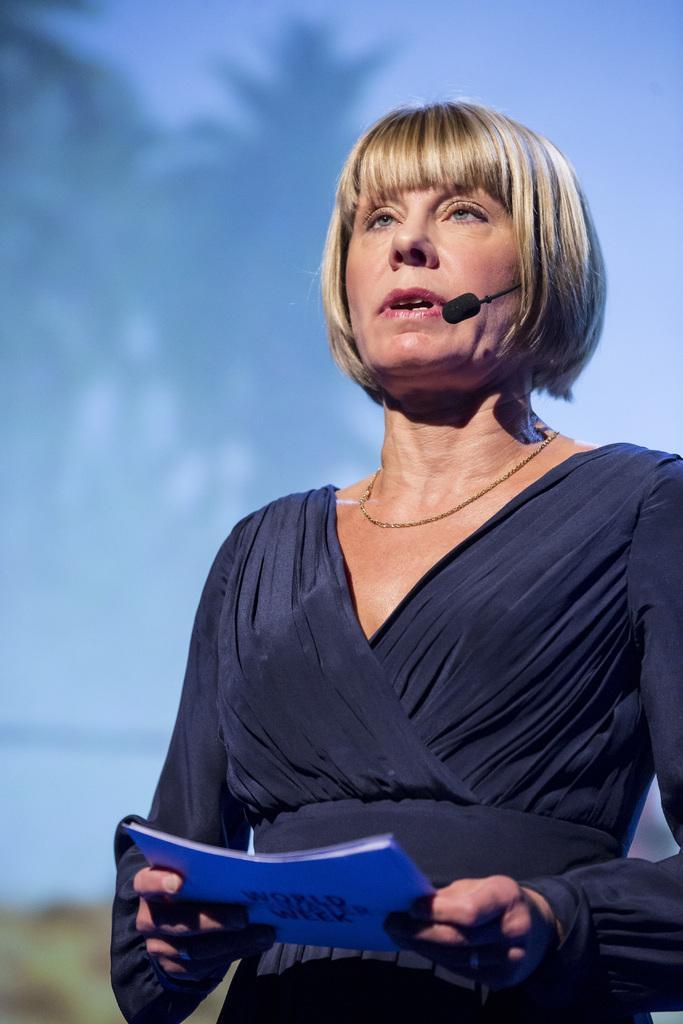Can you describe this image briefly? In this picture there is a woman standing and holding a book and talking. In the background of the image it is not clear. 